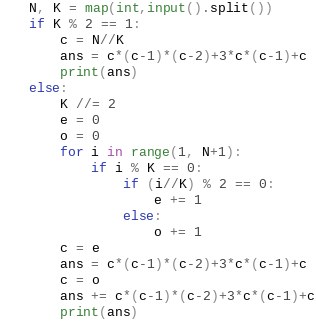<code> <loc_0><loc_0><loc_500><loc_500><_Python_>N, K = map(int,input().split())
if K % 2 == 1:
    c = N//K
    ans = c*(c-1)*(c-2)+3*c*(c-1)+c
    print(ans)
else:
    K //= 2
    e = 0
    o = 0
    for i in range(1, N+1):
        if i % K == 0:
            if (i//K) % 2 == 0:
                e += 1
            else:
                o += 1
    c = e
    ans = c*(c-1)*(c-2)+3*c*(c-1)+c
    c = o
    ans += c*(c-1)*(c-2)+3*c*(c-1)+c
    print(ans)</code> 